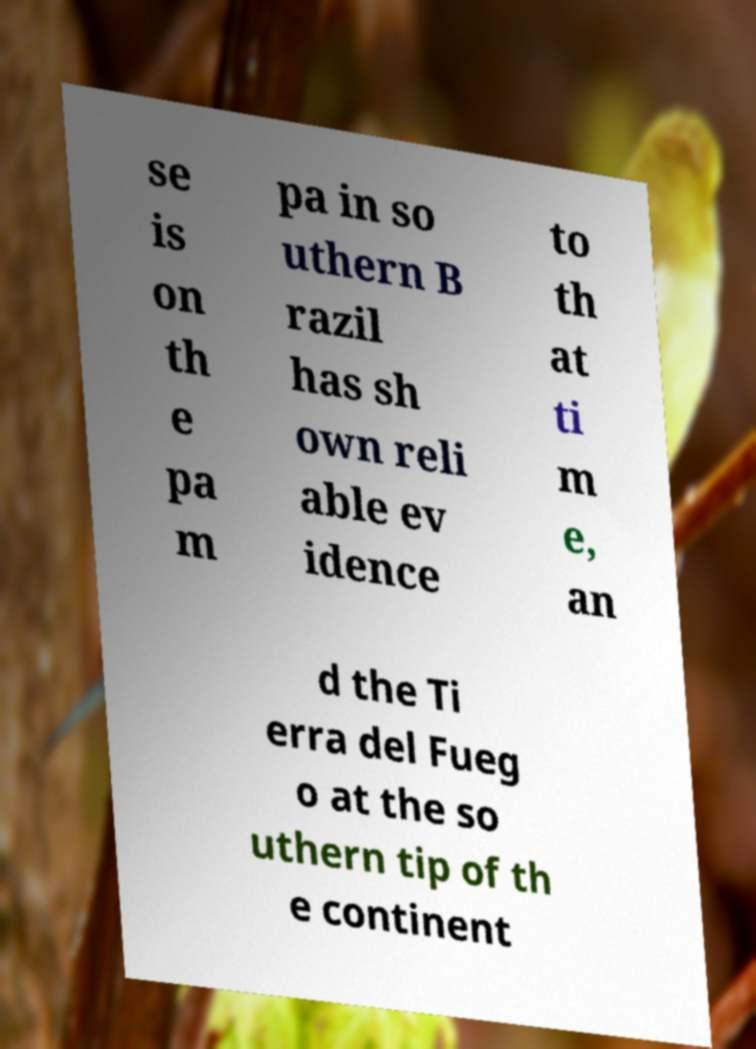Please identify and transcribe the text found in this image. se is on th e pa m pa in so uthern B razil has sh own reli able ev idence to th at ti m e, an d the Ti erra del Fueg o at the so uthern tip of th e continent 